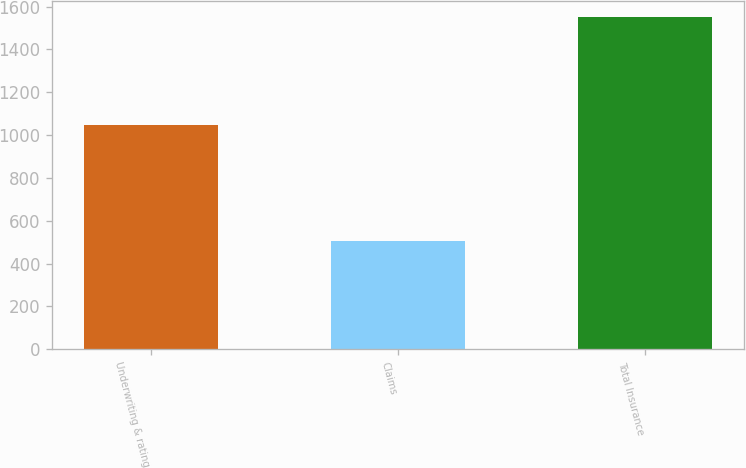Convert chart. <chart><loc_0><loc_0><loc_500><loc_500><bar_chart><fcel>Underwriting & rating<fcel>Claims<fcel>Total Insurance<nl><fcel>1046.9<fcel>503.7<fcel>1550.6<nl></chart> 